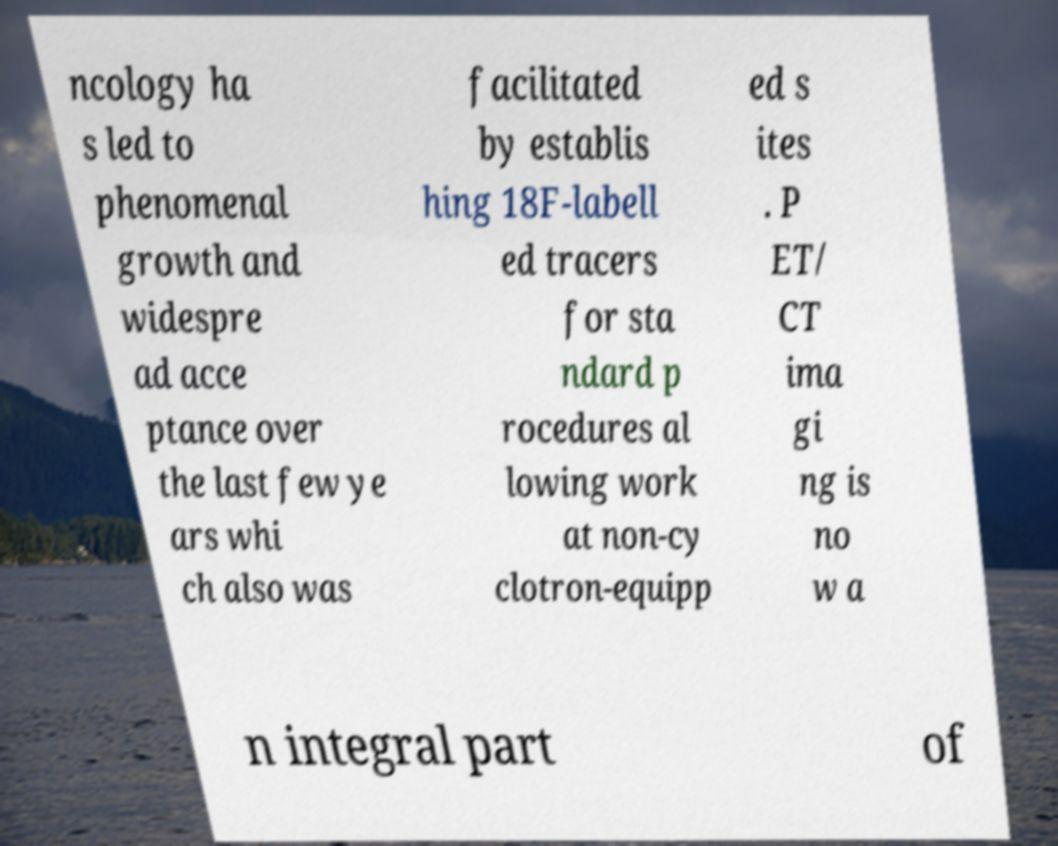There's text embedded in this image that I need extracted. Can you transcribe it verbatim? ncology ha s led to phenomenal growth and widespre ad acce ptance over the last few ye ars whi ch also was facilitated by establis hing 18F-labell ed tracers for sta ndard p rocedures al lowing work at non-cy clotron-equipp ed s ites . P ET/ CT ima gi ng is no w a n integral part of 